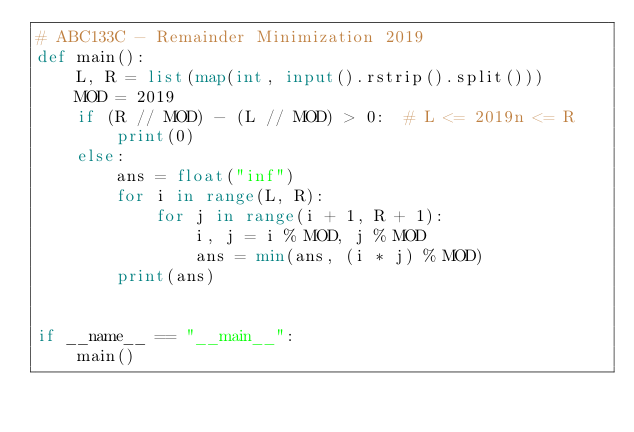Convert code to text. <code><loc_0><loc_0><loc_500><loc_500><_Python_># ABC133C - Remainder Minimization 2019
def main():
    L, R = list(map(int, input().rstrip().split()))
    MOD = 2019
    if (R // MOD) - (L // MOD) > 0:  # L <= 2019n <= R
        print(0)
    else:
        ans = float("inf")
        for i in range(L, R):
            for j in range(i + 1, R + 1):
                i, j = i % MOD, j % MOD
                ans = min(ans, (i * j) % MOD)
        print(ans)


if __name__ == "__main__":
    main()</code> 